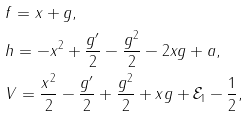<formula> <loc_0><loc_0><loc_500><loc_500>& f = x + g , \\ & h = - x ^ { 2 } + \frac { g ^ { \prime } } { 2 } - \frac { g ^ { 2 } } { 2 } - 2 x g + a , \\ & V = \frac { x ^ { 2 } } 2 - \frac { g ^ { \prime } } 2 + \frac { g ^ { 2 } } 2 + x g + \mathcal { E } _ { 1 } - \frac { 1 } { 2 } ,</formula> 